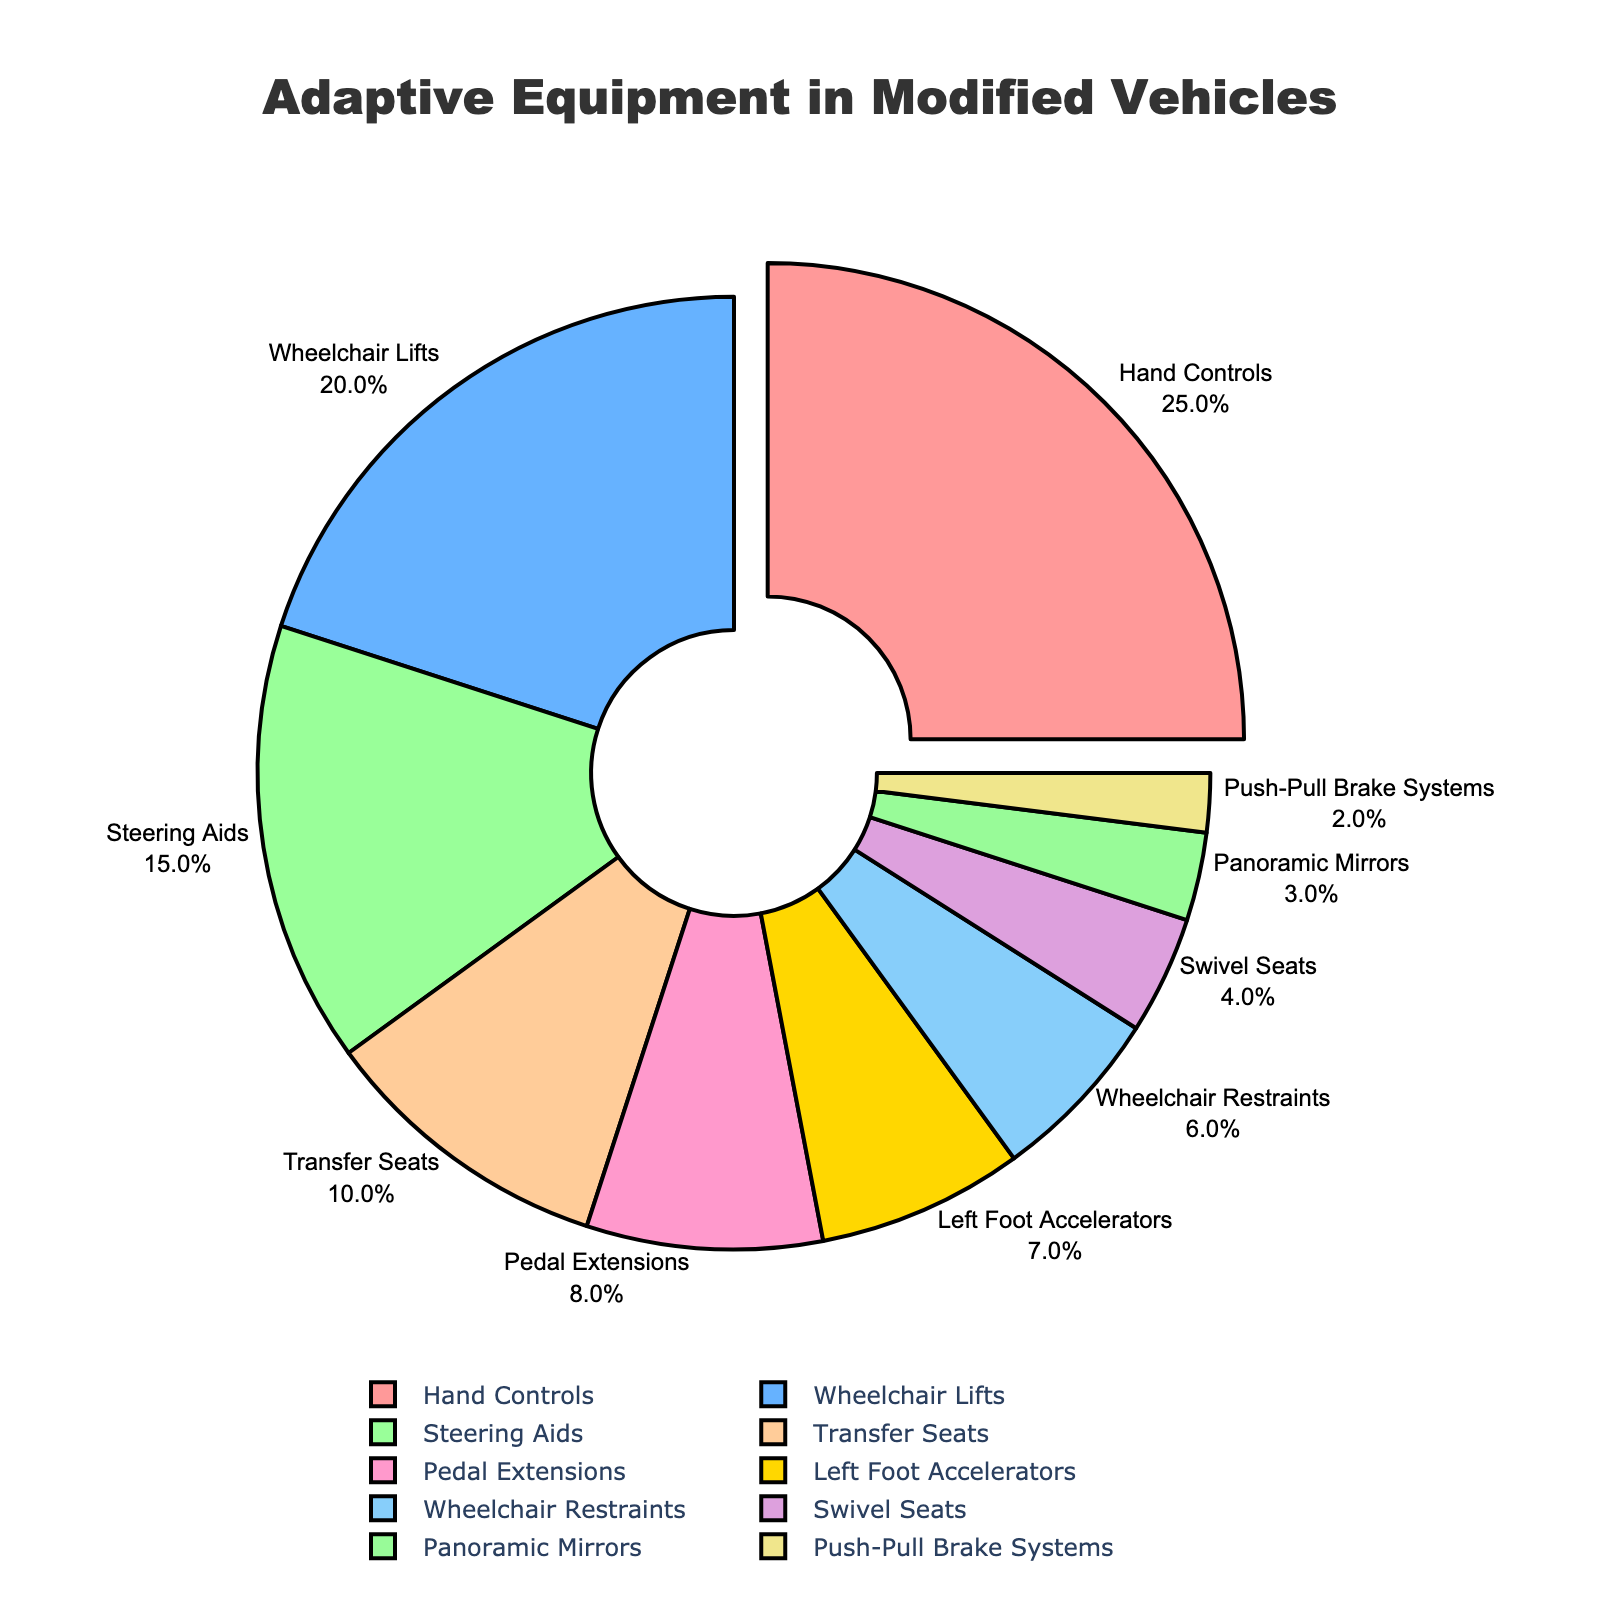What is the percentage of adaptive equipment installed in vehicles that use hand controls? The "Hand Controls" category is highlighted in the pie chart with a percentage displayed next to it.
Answer: 25% Which category has a higher percentage of installation: Wheelchair Lifts or Steering Aids? Locate both "Wheelchair Lifts" and "Steering Aids" in the pie chart. Wheelchair Lifts show 20% while Steering Aids show 15%.
Answer: Wheelchair Lifts What is the combined percentage of Transfer Seats, Pedal Extensions, and Left Foot Accelerators? Locate the individual percentages for Transfer Seats (10%), Pedal Extensions (8%), and Left Foot Accelerators (7%). Add them together: 10 + 8 + 7 = 25
Answer: 25% Which adaptive equipment category has the smallest percentage representation? Look for the slice with the smallest percentage. The "Push-Pull Brake Systems" category shows the smallest slice with a percentage of 2%.
Answer: Push-Pull Brake Systems How much more common are Hand Controls compared to Left Foot Accelerators? Hand Controls have a percentage of 25%, and Left Foot Accelerators have 7%. Subtract the smaller percentage from the larger: 25 - 7 = 18.
Answer: 18% What is the combined percentage of the three least common adaptive equipment categories? Identify the three smallest percentages: Push-Pull Brake Systems (2%), Panoramic Mirrors (3%), and Swivel Seats (4%). Add them together: 2 + 3 + 4 = 9.
Answer: 9% What is the difference in percentage between Wheelchair Restraints and Pedal Extensions? Wheelchair Restraints have 6%, and Pedal Extensions have 8%. Subtract the smaller percentage from the larger: 8 - 6 = 2.
Answer: 2% Which category has a lower percentage, Swivel Seats or Panoramic Mirrors? Swivel Seats show 4%, and Panoramic Mirrors show 3%. Compare the two values.
Answer: Panoramic Mirrors 